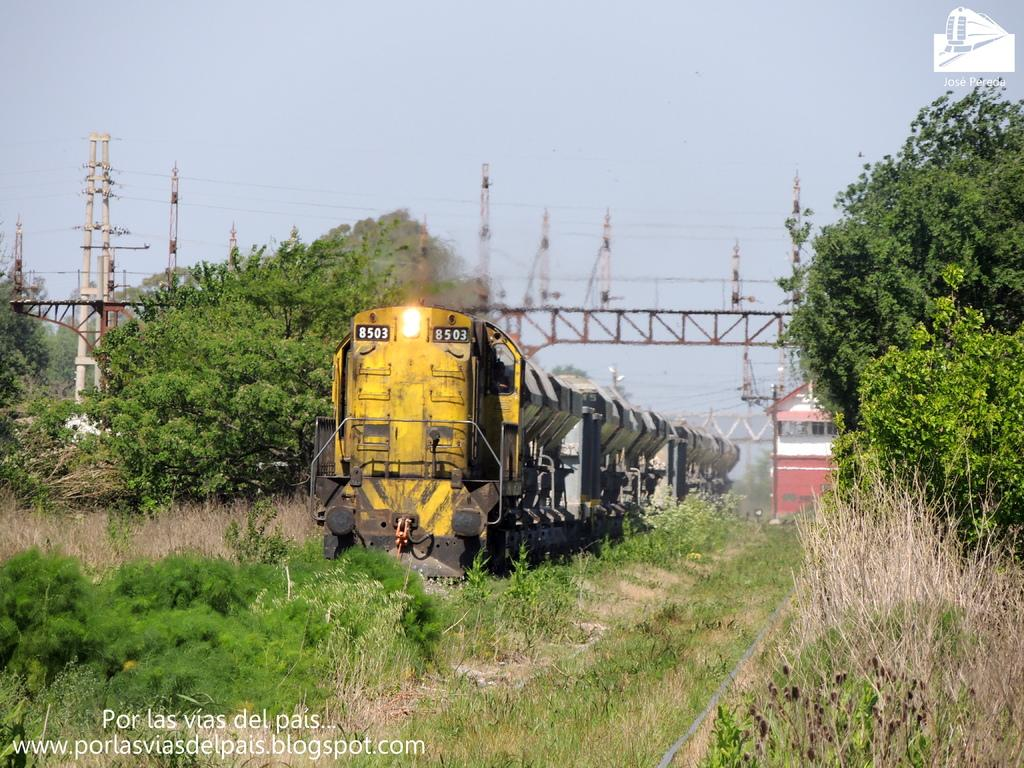What is the main subject of the image? There is a train in the image. What color is the train? The train is yellow. Can you describe any other objects or features in the image? There is a light visible in the image, and there are trees and towers in the background. What color are the trees? The trees are green. How would you describe the sky in the image? The sky is white in color. How many knots are tied on the train in the image? There are no knots present in the image, as it features a train and not a rope or any object that can be tied in knots. 